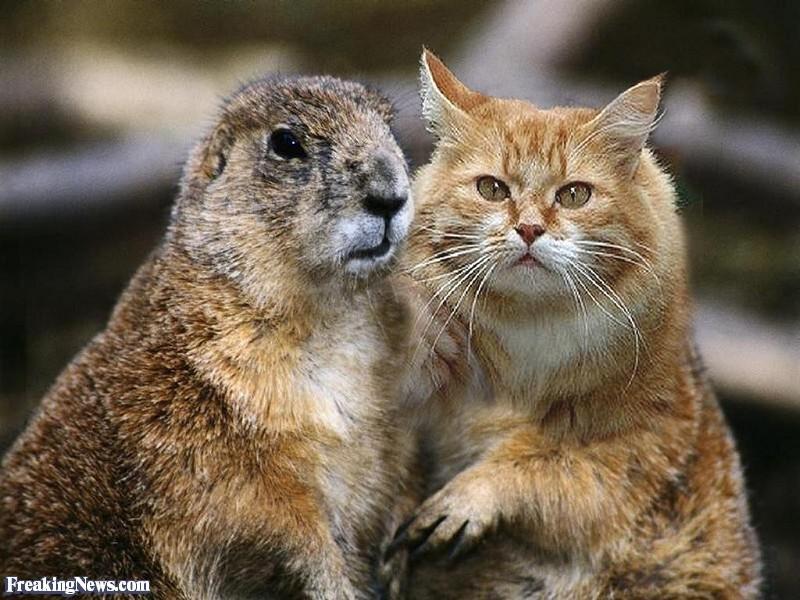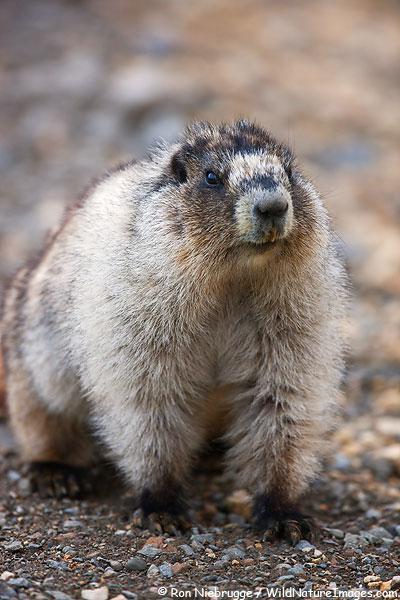The first image is the image on the left, the second image is the image on the right. Considering the images on both sides, is "At least one image contains two animals." valid? Answer yes or no. Yes. 